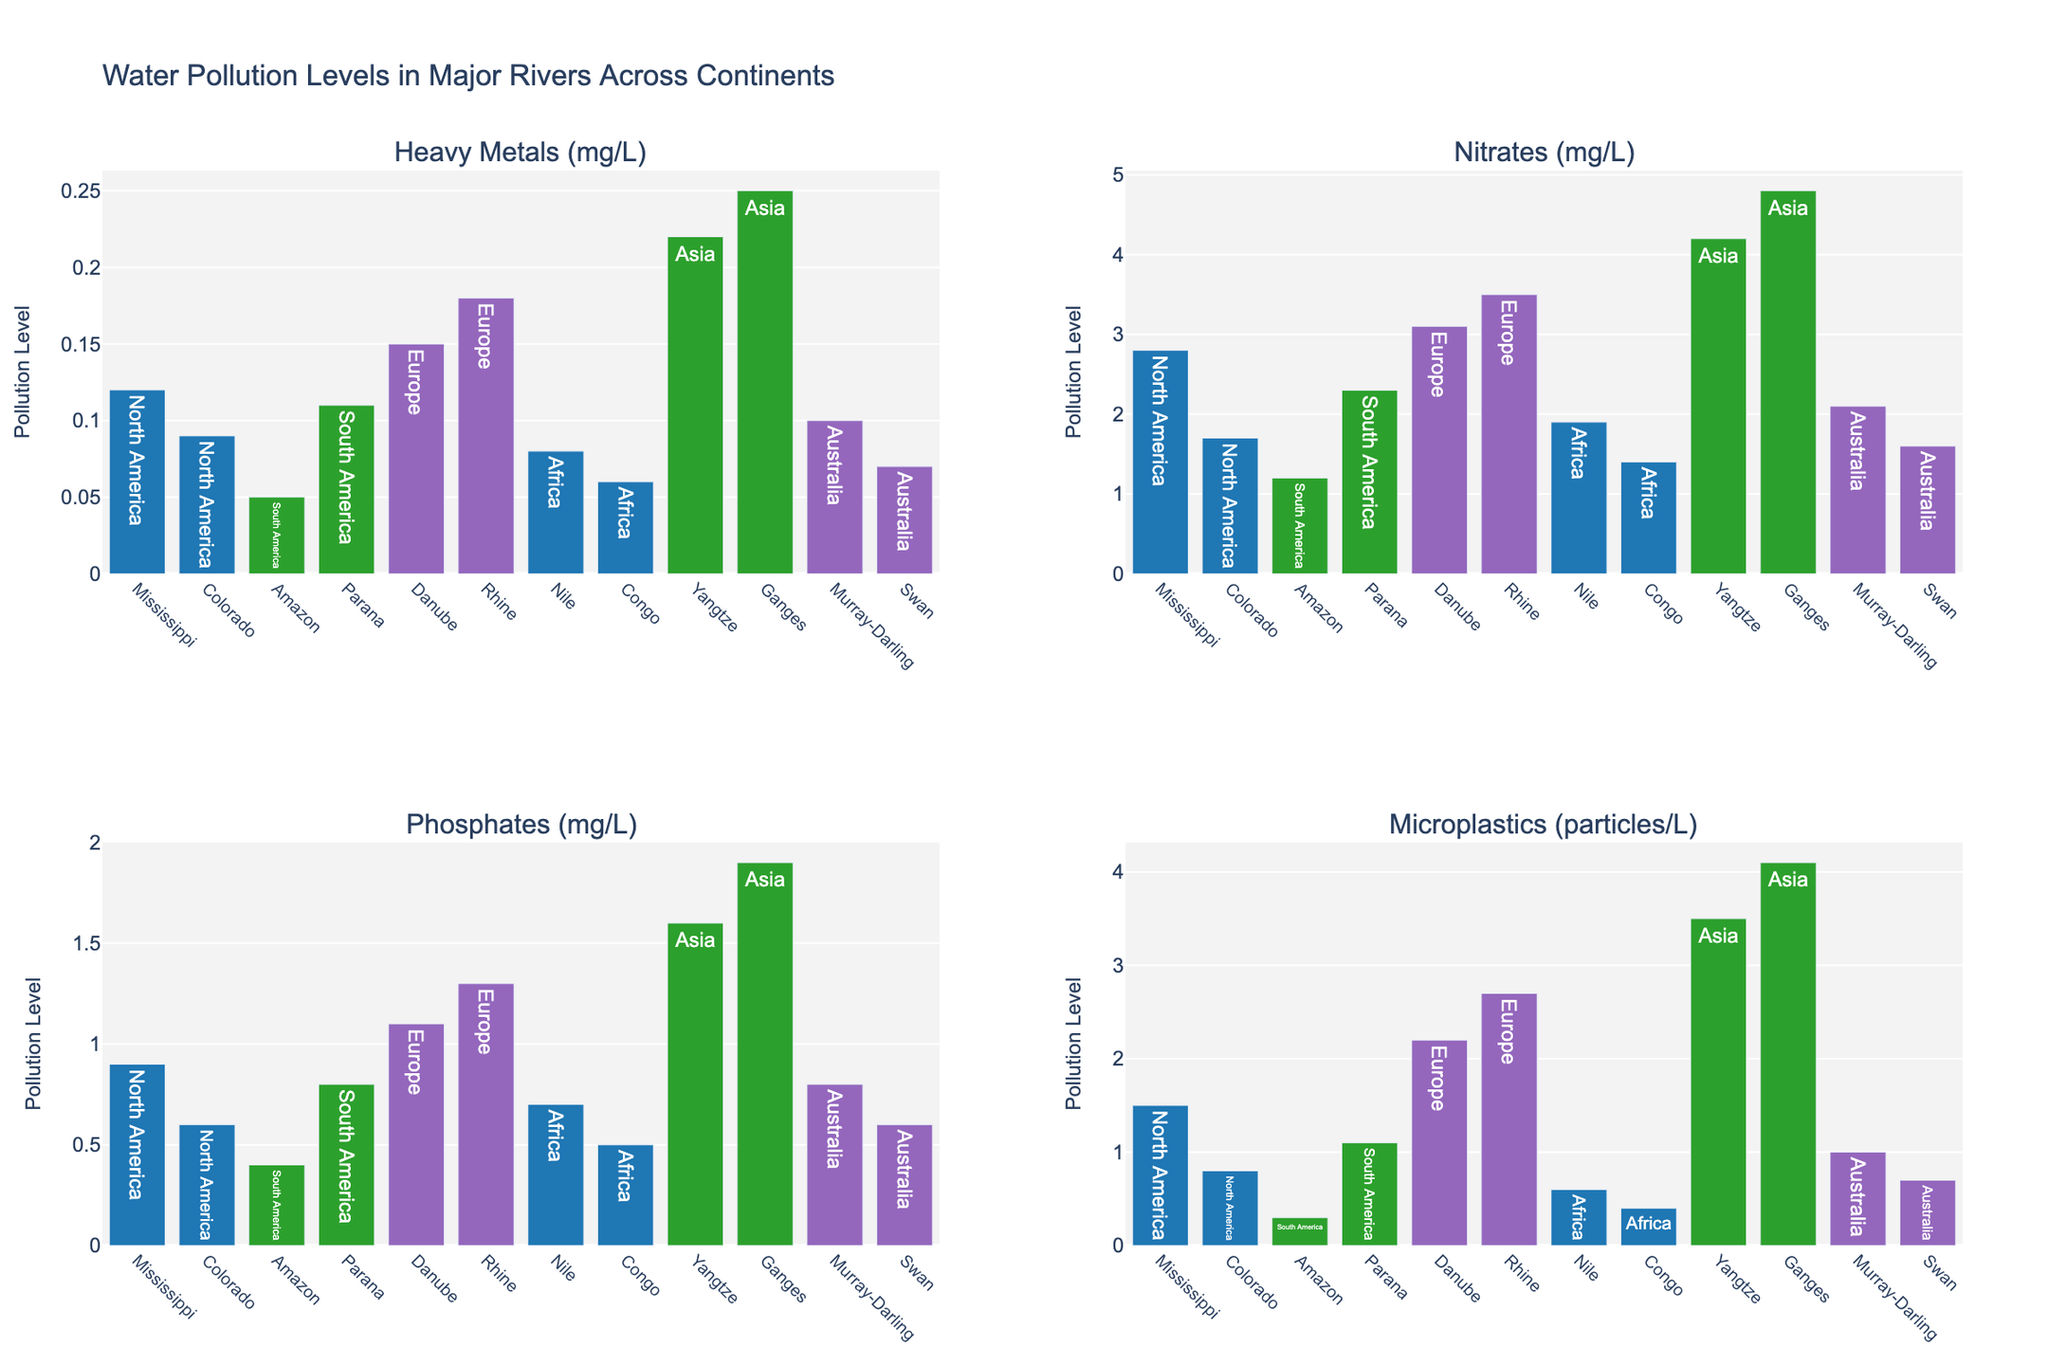Which river in North America has the highest level of heavy metals? Compare the bars for heavy metals in the rivers of North America and identify which bar is the tallest. The Mississippi River has the highest level of heavy metals in North America.
Answer: Mississippi River What is the sum of nitrate levels in the Ganges and Yangtze rivers? Look at the bars for nitrates in the Ganges and Yangtze rivers: Ganges (4.8 mg/L) and Yangtze (4.2 mg/L). Add these values together: 4.8 + 4.2 = 9 mg/L.
Answer: 9 mg/L How does the microplastic level in the Amazon River compare to that in the Danube River? Check the bars for microplastics in both rivers. The Amazon River has a microplastic level of 0.3 particles/L, and the Danube River has a level of 2.2 particles/L. The Amazon River's level is lower than the Danube River's.
Answer: Lower Which continent has the river with the highest level of phosphates? Identify the highest bar in the phosphates subplot. The Ganges River in Asia has the highest phosphate level at 1.9 mg/L.
Answer: Asia What is the average level of phosphates in Australian rivers? Find the values for phosphates in the Murray-Darling (0.8 mg/L) and Swan (0.6 mg/L) rivers. Calculate the average: (0.8 + 0.6) / 2 = 0.7 mg/L.
Answer: 0.7 mg/L Is the level of heavy metals in the Nile River greater than that in the Colorado River? Look at the bars for heavy metals in the Nile (0.08 mg/L) and Colorado (0.09 mg/L) rivers. The Nile River's level is lower than the Colorado River's level.
Answer: No Which river has the lowest level of any single pollutant, and what is that pollutant? Identify the smallest bar in all subplots. The Amazon River has the lowest single pollutant level for microplastics at 0.3 particles/L.
Answer: Amazon River for microplastics Compare the levels of nitrates in European rivers. Which river has the higher value? Compare nitrate levels in the Danube (3.1 mg/L) and Rhine (3.5 mg/L) rivers. The Rhine River has the higher value for nitrates.
Answer: Rhine River What is the difference in heavy metal levels between the Yangtze and Congo rivers? Check the heavy metals levels for the Yangtze (0.22 mg/L) and Congo (0.06 mg/L). Subtract the Congo's level from the Yangtze's level: 0.22 - 0.06 = 0.16 mg/L.
Answer: 0.16 mg/L 